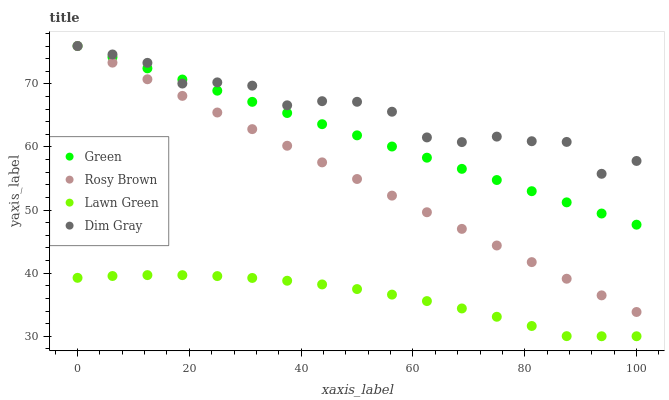Does Lawn Green have the minimum area under the curve?
Answer yes or no. Yes. Does Dim Gray have the maximum area under the curve?
Answer yes or no. Yes. Does Rosy Brown have the minimum area under the curve?
Answer yes or no. No. Does Rosy Brown have the maximum area under the curve?
Answer yes or no. No. Is Rosy Brown the smoothest?
Answer yes or no. Yes. Is Dim Gray the roughest?
Answer yes or no. Yes. Is Dim Gray the smoothest?
Answer yes or no. No. Is Rosy Brown the roughest?
Answer yes or no. No. Does Lawn Green have the lowest value?
Answer yes or no. Yes. Does Rosy Brown have the lowest value?
Answer yes or no. No. Does Green have the highest value?
Answer yes or no. Yes. Is Lawn Green less than Dim Gray?
Answer yes or no. Yes. Is Dim Gray greater than Lawn Green?
Answer yes or no. Yes. Does Green intersect Dim Gray?
Answer yes or no. Yes. Is Green less than Dim Gray?
Answer yes or no. No. Is Green greater than Dim Gray?
Answer yes or no. No. Does Lawn Green intersect Dim Gray?
Answer yes or no. No. 